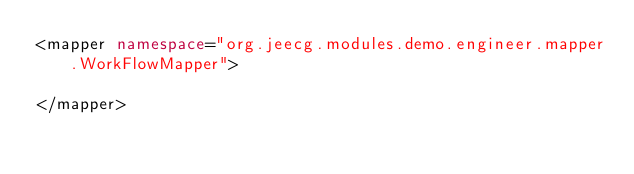<code> <loc_0><loc_0><loc_500><loc_500><_XML_><mapper namespace="org.jeecg.modules.demo.engineer.mapper.WorkFlowMapper">

</mapper></code> 